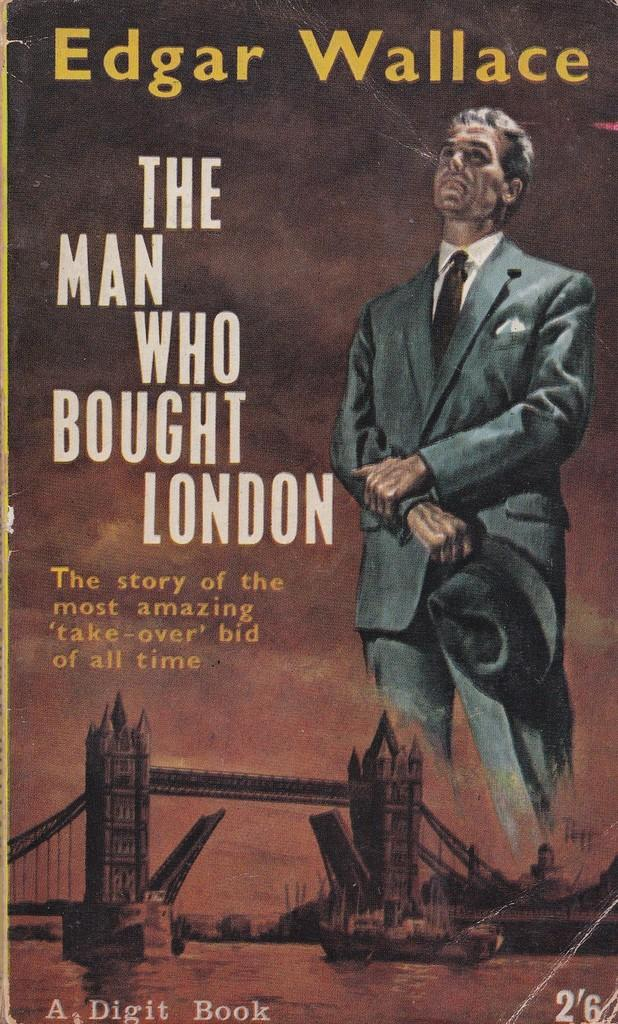What type of image is shown in the picture? The image is of a poster. What is depicted on the poster? There is a depiction of a person and a bridge on the poster. What type of bread can be seen on the bridge in the image? There is no bread present in the image; it features a depiction of a person and a bridge on a poster. 